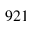<formula> <loc_0><loc_0><loc_500><loc_500>9 2 1</formula> 